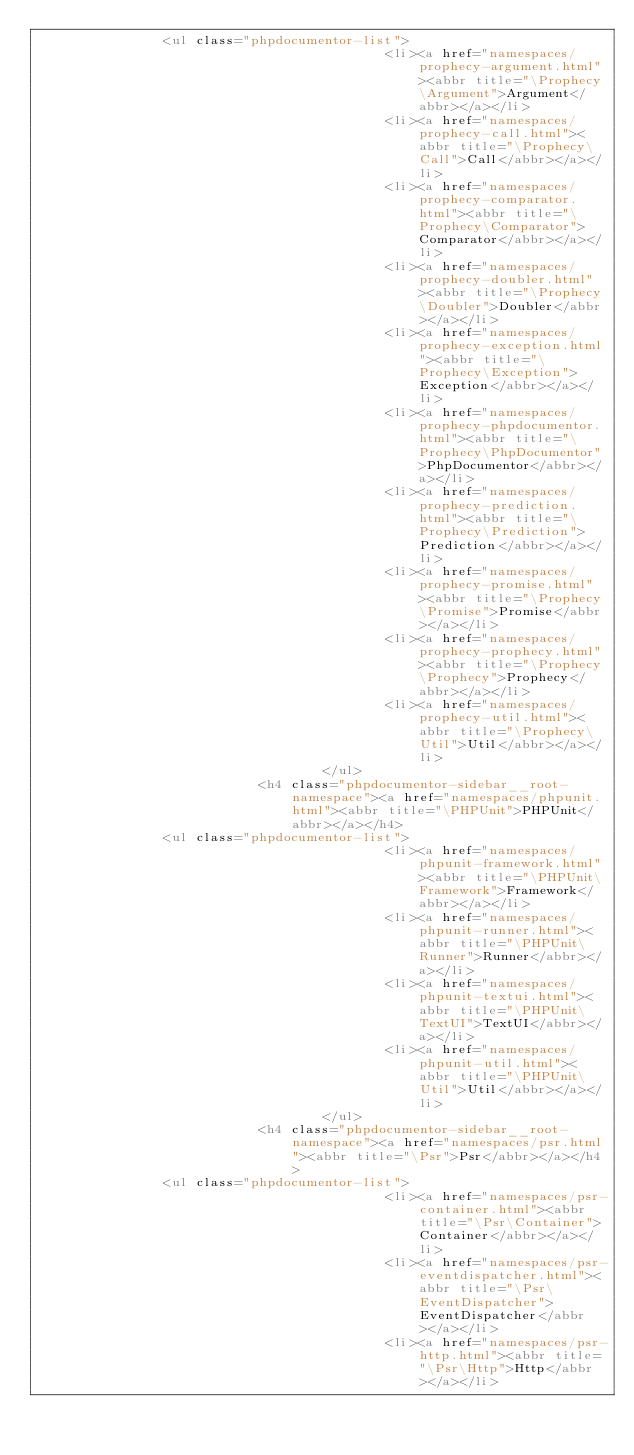<code> <loc_0><loc_0><loc_500><loc_500><_HTML_>                <ul class="phpdocumentor-list">
                                            <li><a href="namespaces/prophecy-argument.html"><abbr title="\Prophecy\Argument">Argument</abbr></a></li>
                                            <li><a href="namespaces/prophecy-call.html"><abbr title="\Prophecy\Call">Call</abbr></a></li>
                                            <li><a href="namespaces/prophecy-comparator.html"><abbr title="\Prophecy\Comparator">Comparator</abbr></a></li>
                                            <li><a href="namespaces/prophecy-doubler.html"><abbr title="\Prophecy\Doubler">Doubler</abbr></a></li>
                                            <li><a href="namespaces/prophecy-exception.html"><abbr title="\Prophecy\Exception">Exception</abbr></a></li>
                                            <li><a href="namespaces/prophecy-phpdocumentor.html"><abbr title="\Prophecy\PhpDocumentor">PhpDocumentor</abbr></a></li>
                                            <li><a href="namespaces/prophecy-prediction.html"><abbr title="\Prophecy\Prediction">Prediction</abbr></a></li>
                                            <li><a href="namespaces/prophecy-promise.html"><abbr title="\Prophecy\Promise">Promise</abbr></a></li>
                                            <li><a href="namespaces/prophecy-prophecy.html"><abbr title="\Prophecy\Prophecy">Prophecy</abbr></a></li>
                                            <li><a href="namespaces/prophecy-util.html"><abbr title="\Prophecy\Util">Util</abbr></a></li>
                                    </ul>
                            <h4 class="phpdocumentor-sidebar__root-namespace"><a href="namespaces/phpunit.html"><abbr title="\PHPUnit">PHPUnit</abbr></a></h4>
                <ul class="phpdocumentor-list">
                                            <li><a href="namespaces/phpunit-framework.html"><abbr title="\PHPUnit\Framework">Framework</abbr></a></li>
                                            <li><a href="namespaces/phpunit-runner.html"><abbr title="\PHPUnit\Runner">Runner</abbr></a></li>
                                            <li><a href="namespaces/phpunit-textui.html"><abbr title="\PHPUnit\TextUI">TextUI</abbr></a></li>
                                            <li><a href="namespaces/phpunit-util.html"><abbr title="\PHPUnit\Util">Util</abbr></a></li>
                                    </ul>
                            <h4 class="phpdocumentor-sidebar__root-namespace"><a href="namespaces/psr.html"><abbr title="\Psr">Psr</abbr></a></h4>
                <ul class="phpdocumentor-list">
                                            <li><a href="namespaces/psr-container.html"><abbr title="\Psr\Container">Container</abbr></a></li>
                                            <li><a href="namespaces/psr-eventdispatcher.html"><abbr title="\Psr\EventDispatcher">EventDispatcher</abbr></a></li>
                                            <li><a href="namespaces/psr-http.html"><abbr title="\Psr\Http">Http</abbr></a></li></code> 